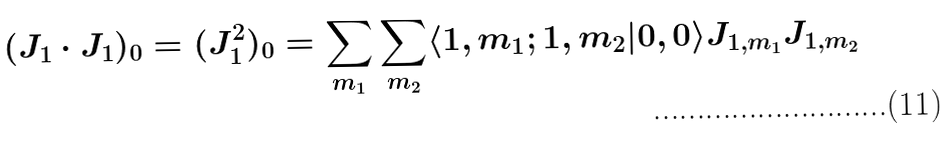<formula> <loc_0><loc_0><loc_500><loc_500>( J _ { 1 } \cdot J _ { 1 } ) _ { 0 } = ( J _ { 1 } ^ { 2 } ) _ { 0 } = \sum _ { m _ { 1 } } \sum _ { m _ { 2 } } \langle 1 , m _ { 1 } ; 1 , m _ { 2 } | 0 , 0 \rangle J _ { 1 , m _ { 1 } } J _ { 1 , m _ { 2 } }</formula> 